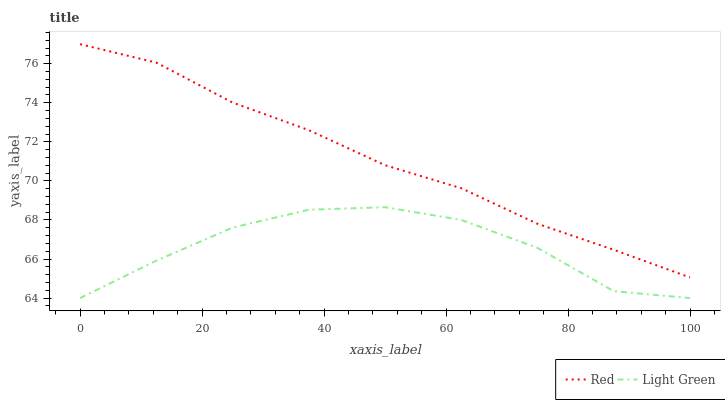Does Red have the minimum area under the curve?
Answer yes or no. No. Is Red the roughest?
Answer yes or no. No. Does Red have the lowest value?
Answer yes or no. No. Is Light Green less than Red?
Answer yes or no. Yes. Is Red greater than Light Green?
Answer yes or no. Yes. Does Light Green intersect Red?
Answer yes or no. No. 